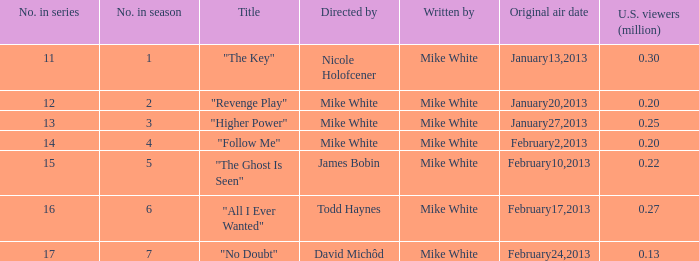In the series, how many episodes were titled "the key"? 1.0. 